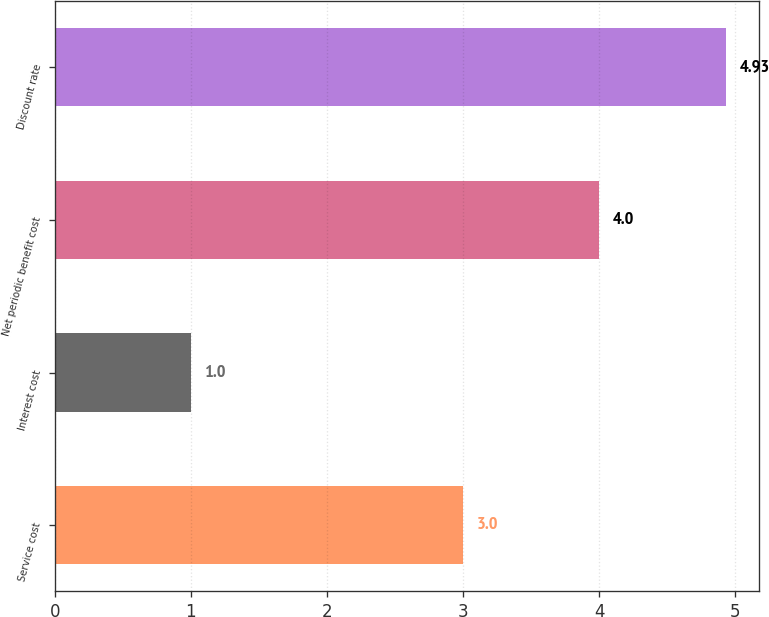Convert chart to OTSL. <chart><loc_0><loc_0><loc_500><loc_500><bar_chart><fcel>Service cost<fcel>Interest cost<fcel>Net periodic benefit cost<fcel>Discount rate<nl><fcel>3<fcel>1<fcel>4<fcel>4.93<nl></chart> 